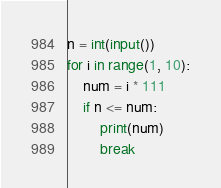Convert code to text. <code><loc_0><loc_0><loc_500><loc_500><_Python_>n = int(input())
for i in range(1, 10):
    num = i * 111
    if n <= num:
        print(num)
        break</code> 